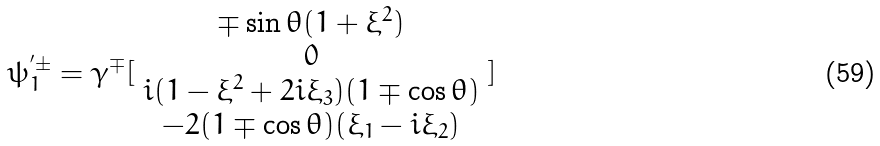<formula> <loc_0><loc_0><loc_500><loc_500>\psi _ { 1 } ^ { ^ { \prime } \pm } = \gamma ^ { \mp } [ \begin{array} { c } \mp \sin \theta ( 1 + \xi ^ { 2 } ) \\ 0 \\ i ( 1 - \xi ^ { 2 } + 2 i \xi _ { 3 } ) ( 1 \mp \cos \theta ) \\ - 2 ( 1 \mp \cos \theta ) ( \xi _ { 1 } - i \xi _ { 2 } ) \end{array} ]</formula> 